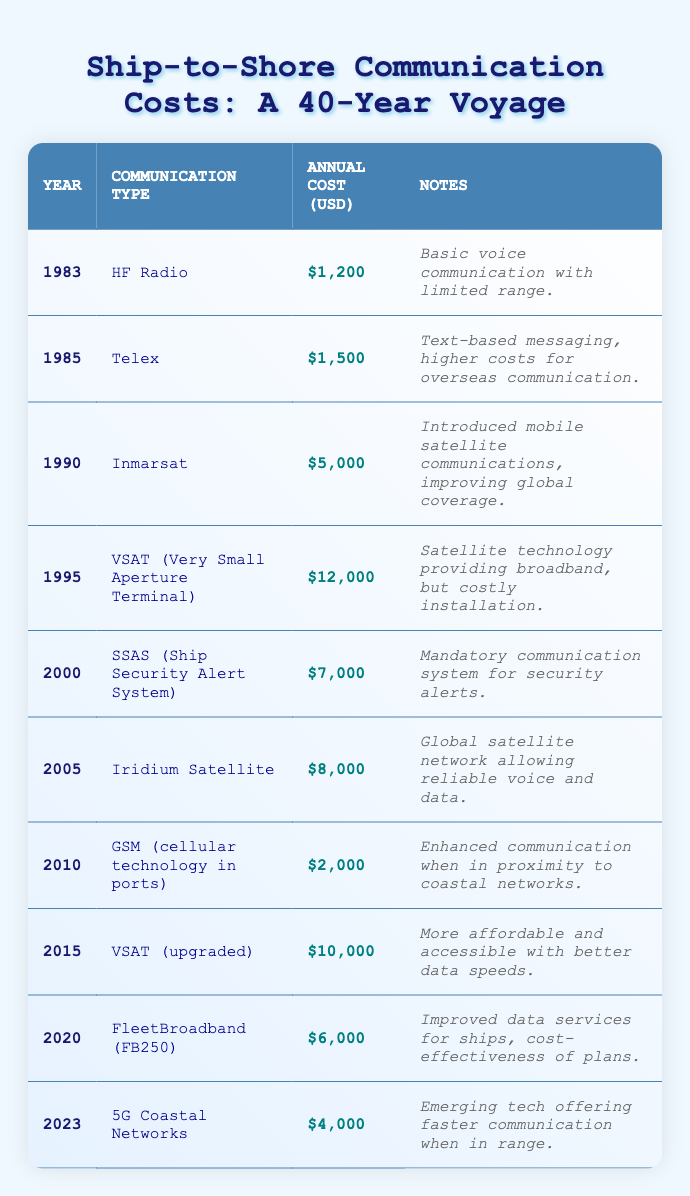What was the cheapest communication method in 1983? In 1983, HF Radio was used for communication, and its annual cost was $1,200. It is the only option listed for that year, making it the cheapest.
Answer: HF Radio Which communication type had the highest annual cost in 1995? In 1995, the costliest communication type was VSAT (Very Small Aperture Terminal), with an annual cost of $12,000.
Answer: VSAT (Very Small Aperture Terminal) What was the average annual cost of communication from 1983 to 2000? Summing the annual costs from 1983 to 2000 gives: 1200 + 1500 + 5000 + 12000 + 7000 = 27,700. There are 5 data points, so the average is 27,700 / 5 = 5,540.
Answer: 5,540 Did the cost of ship-to-shore communication decrease from 2010 to 2023? The annual costs for 2010 and 2023 are $2,000 and $4,000, respectively. Since $4,000 is higher than $2,000, the cost did not decrease.
Answer: No Which communication system was implemented for security alerts, and what was its cost in 2000? The system implemented for security alerts was the SSAS (Ship Security Alert System), and its annual cost in 2000 was $7,000.
Answer: SSAS; $7,000 What was the trend in communication costs between 1990 and 1995? The cost in 1990 was $5,000 and increased to $12,000 in 1995. Since the cost rose during this period, the trend was an increase.
Answer: Increase Which technology offers the fastest communication when in range according to the table? The technology providing the fastest communication when in range in 2023 is 5G Coastal Networks.
Answer: 5G Coastal Networks If a ship used Iridium Satellite in 2005, what would be its total communication expenses from 2000 to 2005? The annual costs are $7,000 (2000) + $8,000 (2005) = $15,000. Thus, total expenses from 2000 to 2005 would be $15,000.
Answer: $15,000 How many communication systems had annual costs below $5,000 over the entire period? The systems costing below $5,000 are HF Radio ($1,200), Telex ($1,500), and GSM ($2,000). This totals 3 systems.
Answer: 3 What was the annual cost difference between the VSAT systems in 1995 and 2015? The cost of VSAT in 1995 was $12,000, and in 2015 it was $10,000. The difference is $12,000 - $10,000 = $2,000.
Answer: $2,000 